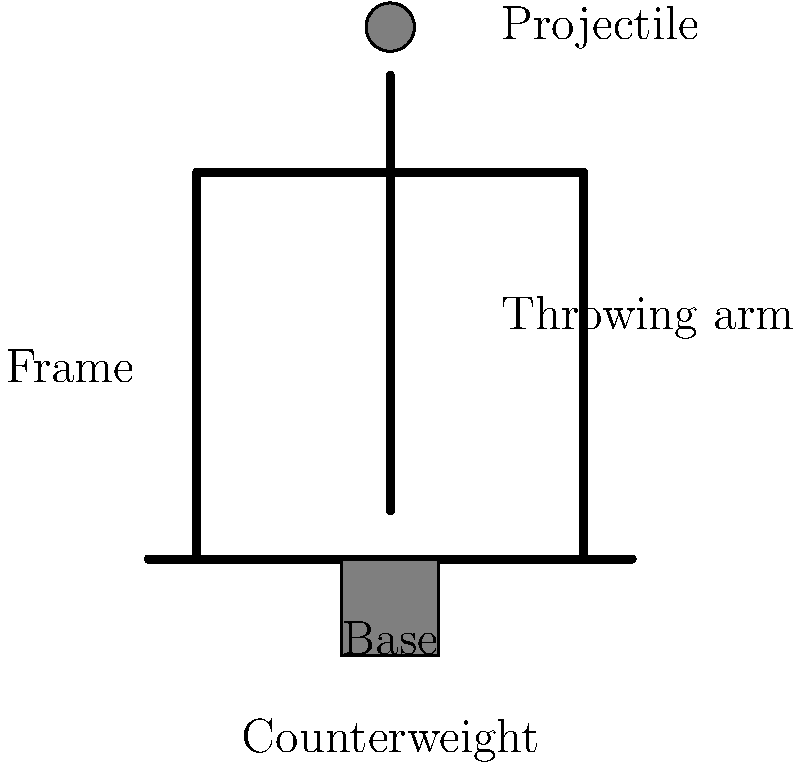Identify the main components of this ancient siege engine, which utilizes gravity and leverage to hurl projectiles over long distances. What is the name of this siege weapon, and how does the counterweight contribute to its function? 1. The diagram illustrates a basic trebuchet, an advanced siege engine used in medieval warfare.

2. Main components:
   a) Base: Provides stability for the entire structure.
   b) Frame: Supports the throwing arm and other components.
   c) Throwing arm: The pivoting beam that swings to launch the projectile.
   d) Projectile: The object being thrown (often a large stone).
   e) Counterweight: A heavy mass at the short end of the throwing arm.

3. The trebuchet works on the principle of leverage and gravitational potential energy:
   a) The counterweight is raised, storing potential energy.
   b) When released, the counterweight falls, converting potential energy to kinetic energy.
   c) This energy is transferred to the longer end of the throwing arm, which swings upward at high speed.
   d) The projectile is released at the optimal point in the arc, launching it towards the target.

4. The counterweight's role:
   a) It provides the main force for the throwing action.
   b) A heavier counterweight allows for throwing heavier projectiles or achieving longer ranges.
   c) The counterweight's mass and the length ratio of the throwing arm determine the trebuchet's power and efficiency.

5. Advantages of the trebuchet:
   a) More accurate and powerful than earlier catapults.
   b) Can launch heavier projectiles over longer distances.
   c) Utilizes gravity, making it more efficient than tension-based siege engines.
Answer: Trebuchet; The counterweight provides the main force for launching, converting gravitational potential energy into kinetic energy of the projectile. 